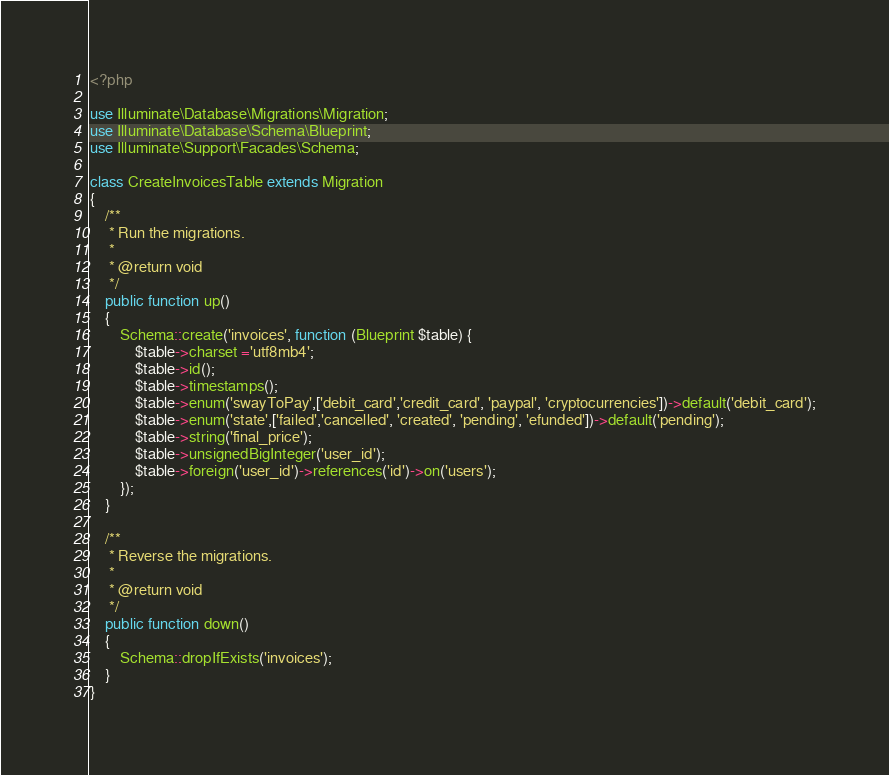Convert code to text. <code><loc_0><loc_0><loc_500><loc_500><_PHP_><?php

use Illuminate\Database\Migrations\Migration;
use Illuminate\Database\Schema\Blueprint;
use Illuminate\Support\Facades\Schema;

class CreateInvoicesTable extends Migration
{
    /**
     * Run the migrations.
     *
     * @return void
     */
    public function up()
    {
        Schema::create('invoices', function (Blueprint $table) {
            $table->charset ='utf8mb4';
            $table->id();
            $table->timestamps();
            $table->enum('swayToPay',['debit_card','credit_card', 'paypal', 'cryptocurrencies'])->default('debit_card');
            $table->enum('state',['failed','cancelled', 'created', 'pending', 'efunded'])->default('pending');
            $table->string('final_price');
            $table->unsignedBigInteger('user_id');
            $table->foreign('user_id')->references('id')->on('users');
        });
    }

    /**
     * Reverse the migrations.
     *
     * @return void
     */
    public function down()
    {
        Schema::dropIfExists('invoices');
    }
}
</code> 